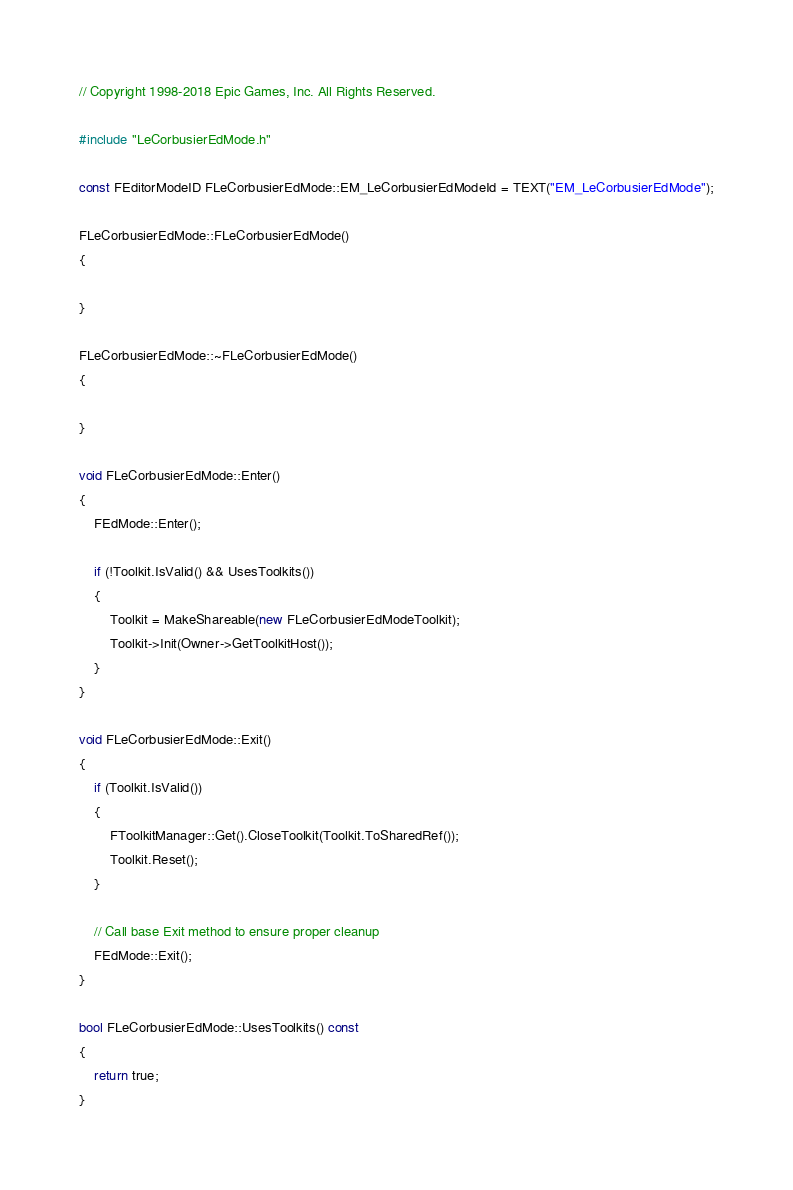<code> <loc_0><loc_0><loc_500><loc_500><_C++_>// Copyright 1998-2018 Epic Games, Inc. All Rights Reserved.

#include "LeCorbusierEdMode.h"

const FEditorModeID FLeCorbusierEdMode::EM_LeCorbusierEdModeId = TEXT("EM_LeCorbusierEdMode");

FLeCorbusierEdMode::FLeCorbusierEdMode()
{

}

FLeCorbusierEdMode::~FLeCorbusierEdMode()
{

}

void FLeCorbusierEdMode::Enter()
{
	FEdMode::Enter();

	if (!Toolkit.IsValid() && UsesToolkits())
	{
		Toolkit = MakeShareable(new FLeCorbusierEdModeToolkit);
		Toolkit->Init(Owner->GetToolkitHost());
	}
}

void FLeCorbusierEdMode::Exit()
{
	if (Toolkit.IsValid())
	{
		FToolkitManager::Get().CloseToolkit(Toolkit.ToSharedRef());
		Toolkit.Reset();
	}

	// Call base Exit method to ensure proper cleanup
	FEdMode::Exit();
}

bool FLeCorbusierEdMode::UsesToolkits() const
{
	return true;
}




</code> 